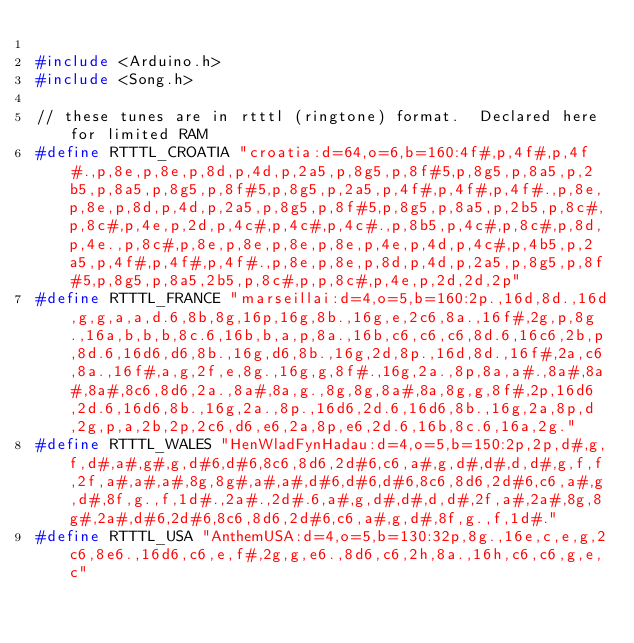<code> <loc_0><loc_0><loc_500><loc_500><_C_>
#include <Arduino.h>
#include <Song.h>

// these tunes are in rtttl (ringtone) format.  Declared here for limited RAM
#define RTTTL_CROATIA "croatia:d=64,o=6,b=160:4f#,p,4f#,p,4f#.,p,8e,p,8e,p,8d,p,4d,p,2a5,p,8g5,p,8f#5,p,8g5,p,8a5,p,2b5,p,8a5,p,8g5,p,8f#5,p,8g5,p,2a5,p,4f#,p,4f#,p,4f#.,p,8e,p,8e,p,8d,p,4d,p,2a5,p,8g5,p,8f#5,p,8g5,p,8a5,p,2b5,p,8c#,p,8c#,p,4e,p,2d,p,4c#,p,4c#,p,4c#.,p,8b5,p,4c#,p,8c#,p,8d,p,4e.,p,8c#,p,8e,p,8e,p,8e,p,8e,p,4e,p,4d,p,4c#,p,4b5,p,2a5,p,4f#,p,4f#,p,4f#.,p,8e,p,8e,p,8d,p,4d,p,2a5,p,8g5,p,8f#5,p,8g5,p,8a5,2b5,p,8c#,p,p,8c#,p,4e,p,2d,2d,2p"
#define RTTTL_FRANCE "marseillai:d=4,o=5,b=160:2p.,16d,8d.,16d,g,g,a,a,d.6,8b,8g,16p,16g,8b.,16g,e,2c6,8a.,16f#,2g,p,8g.,16a,b,b,b,8c.6,16b,b,a,p,8a.,16b,c6,c6,c6,8d.6,16c6,2b,p,8d.6,16d6,d6,8b.,16g,d6,8b.,16g,2d,8p.,16d,8d.,16f#,2a,c6,8a.,16f#,a,g,2f,e,8g.,16g,g,8f#.,16g,2a.,8p,8a,a#.,8a#,8a#,8a#,8c6,8d6,2a.,8a#,8a,g.,8g,8g,8a#,8a,8g,g,8f#,2p,16d6,2d.6,16d6,8b.,16g,2a.,8p.,16d6,2d.6,16d6,8b.,16g,2a,8p,d,2g,p,a,2b,2p,2c6,d6,e6,2a,8p,e6,2d.6,16b,8c.6,16a,2g."
#define RTTTL_WALES "HenWladFynHadau:d=4,o=5,b=150:2p,2p,d#,g,f,d#,a#,g#,g,d#6,d#6,8c6,8d6,2d#6,c6,a#,g,d#,d#,d,d#,g,f,f,2f,a#,a#,a#,8g,8g#,a#,a#,d#6,d#6,d#6,8c6,8d6,2d#6,c6,a#,g,d#,8f,g.,f,1d#.,2a#.,2d#.6,a#,g,d#,d#,d,d#,2f,a#,2a#,8g,8g#,2a#,d#6,2d#6,8c6,8d6,2d#6,c6,a#,g,d#,8f,g.,f,1d#."
#define RTTTL_USA "AnthemUSA:d=4,o=5,b=130:32p,8g.,16e,c,e,g,2c6,8e6.,16d6,c6,e,f#,2g,g,e6.,8d6,c6,2h,8a.,16h,c6,c6,g,e,c"
</code> 